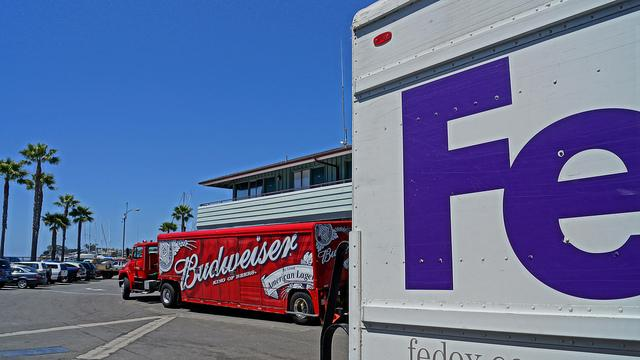What service does the vehicle with the purple letters provide? Please explain your reasoning. deliveries. The vehicle says fed-ex which is a delivery service. 